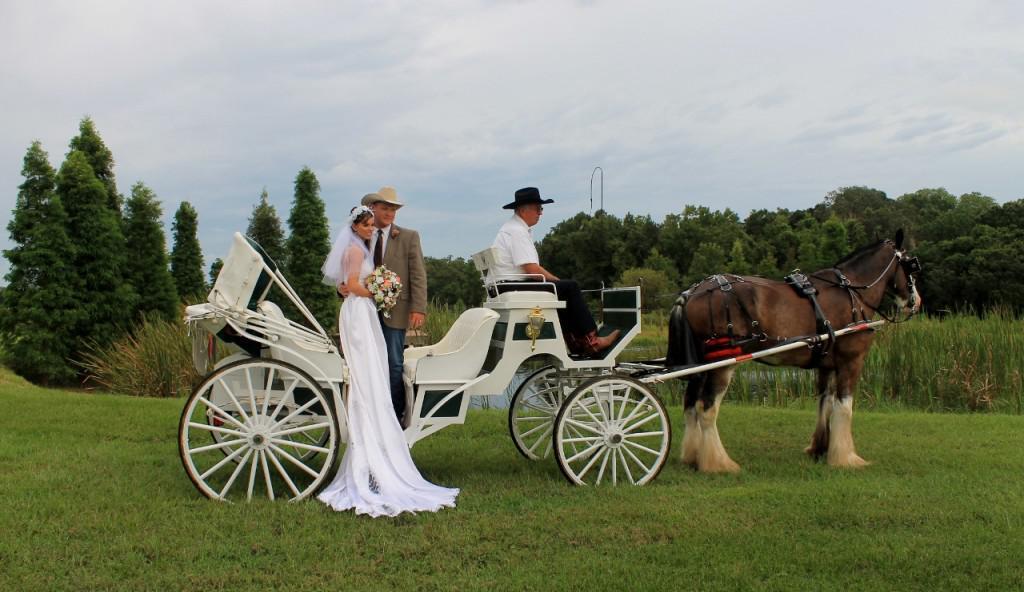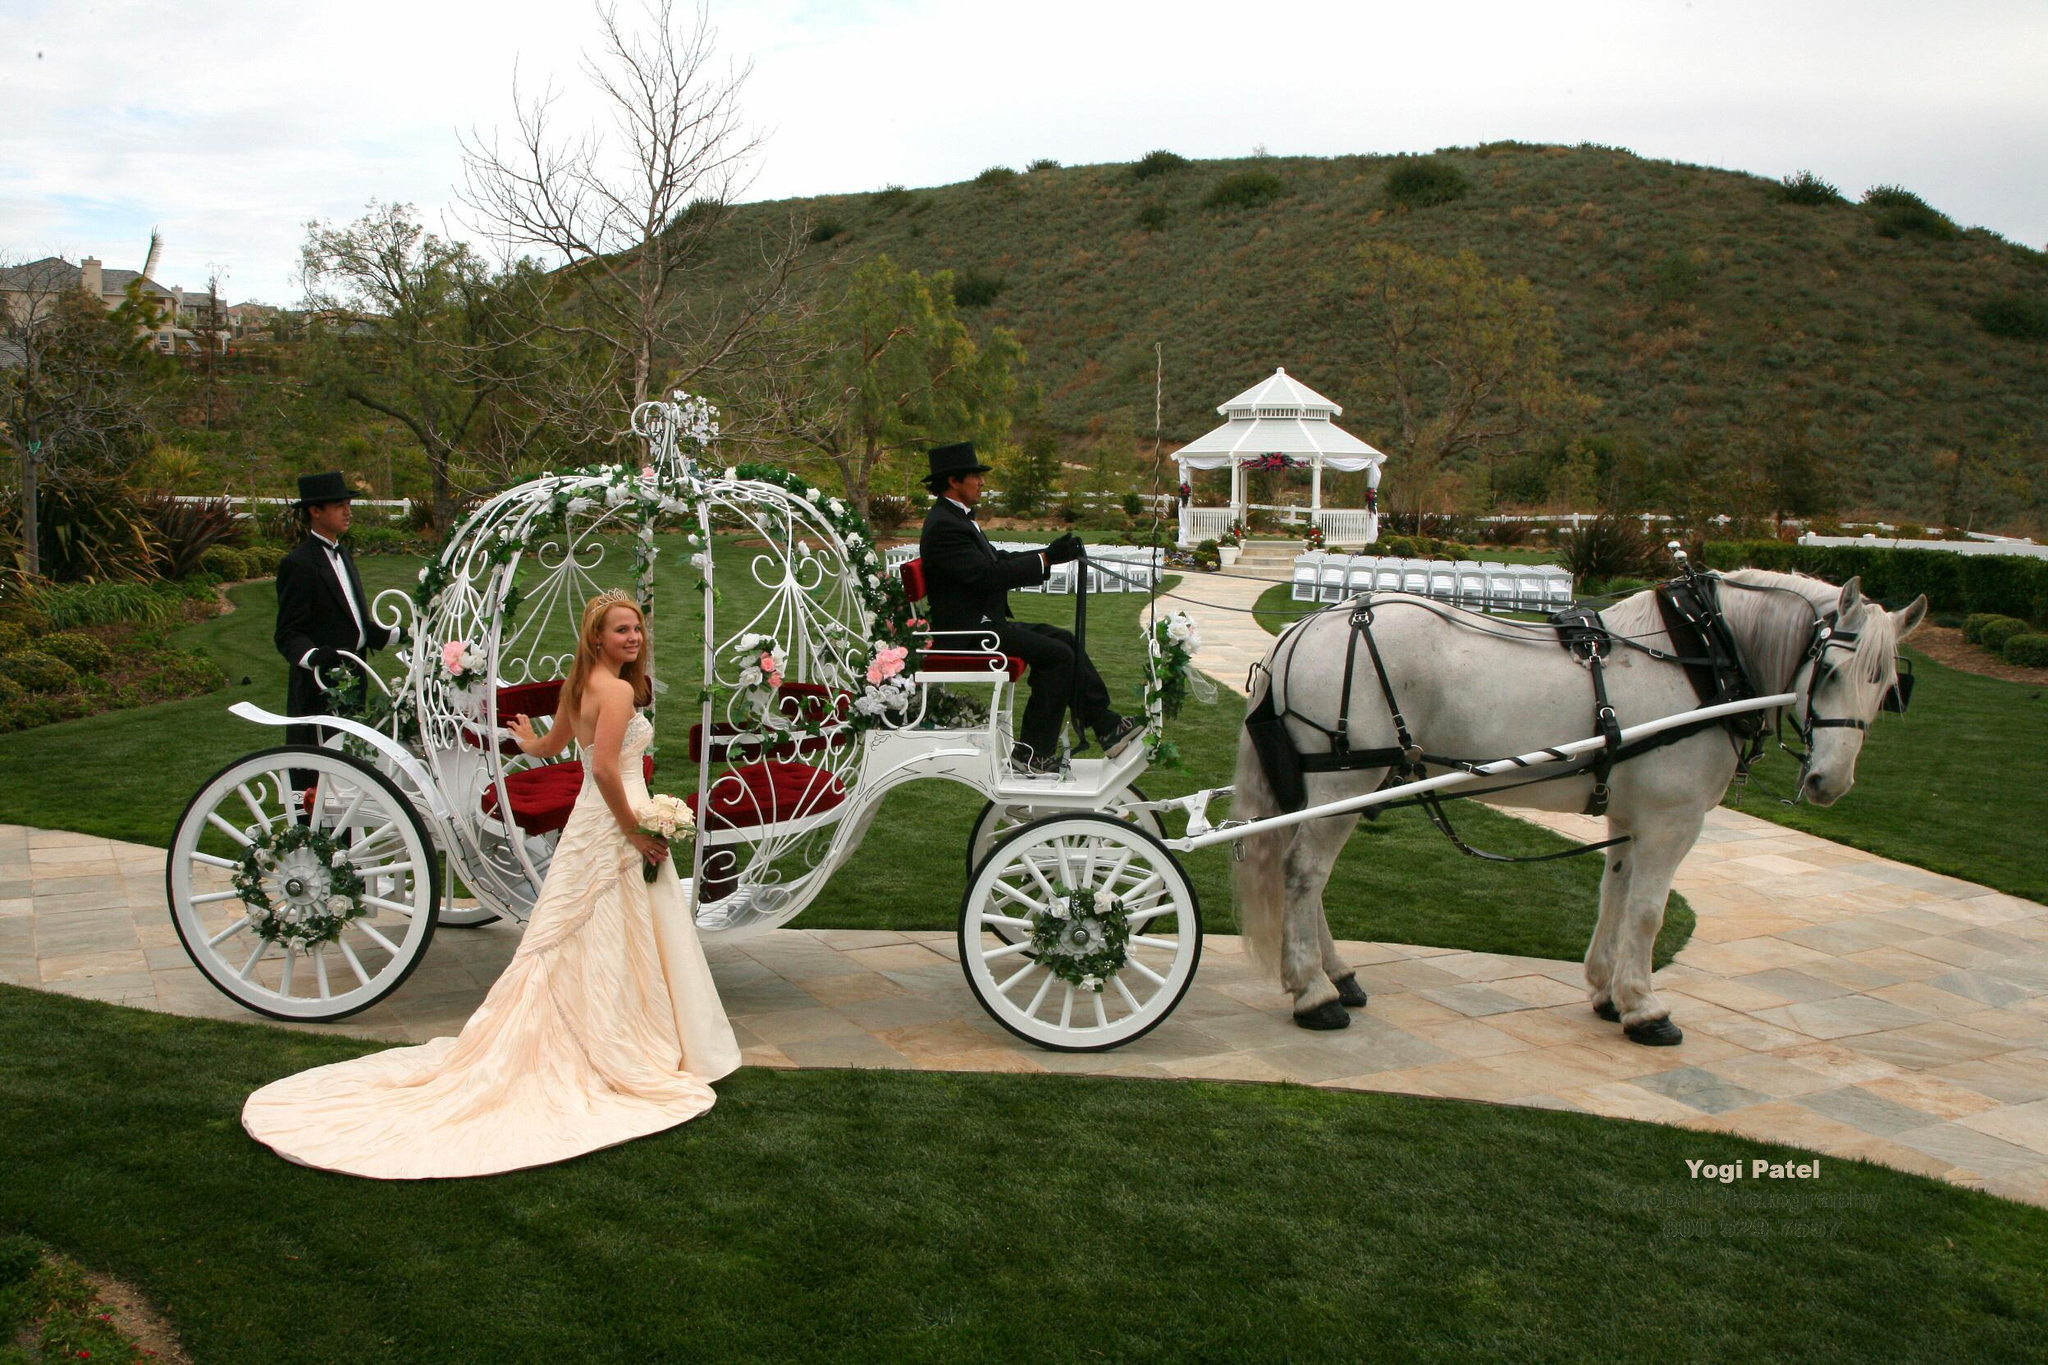The first image is the image on the left, the second image is the image on the right. For the images displayed, is the sentence "The left image shows a carriage pulled by a brown horse." factually correct? Answer yes or no. Yes. 